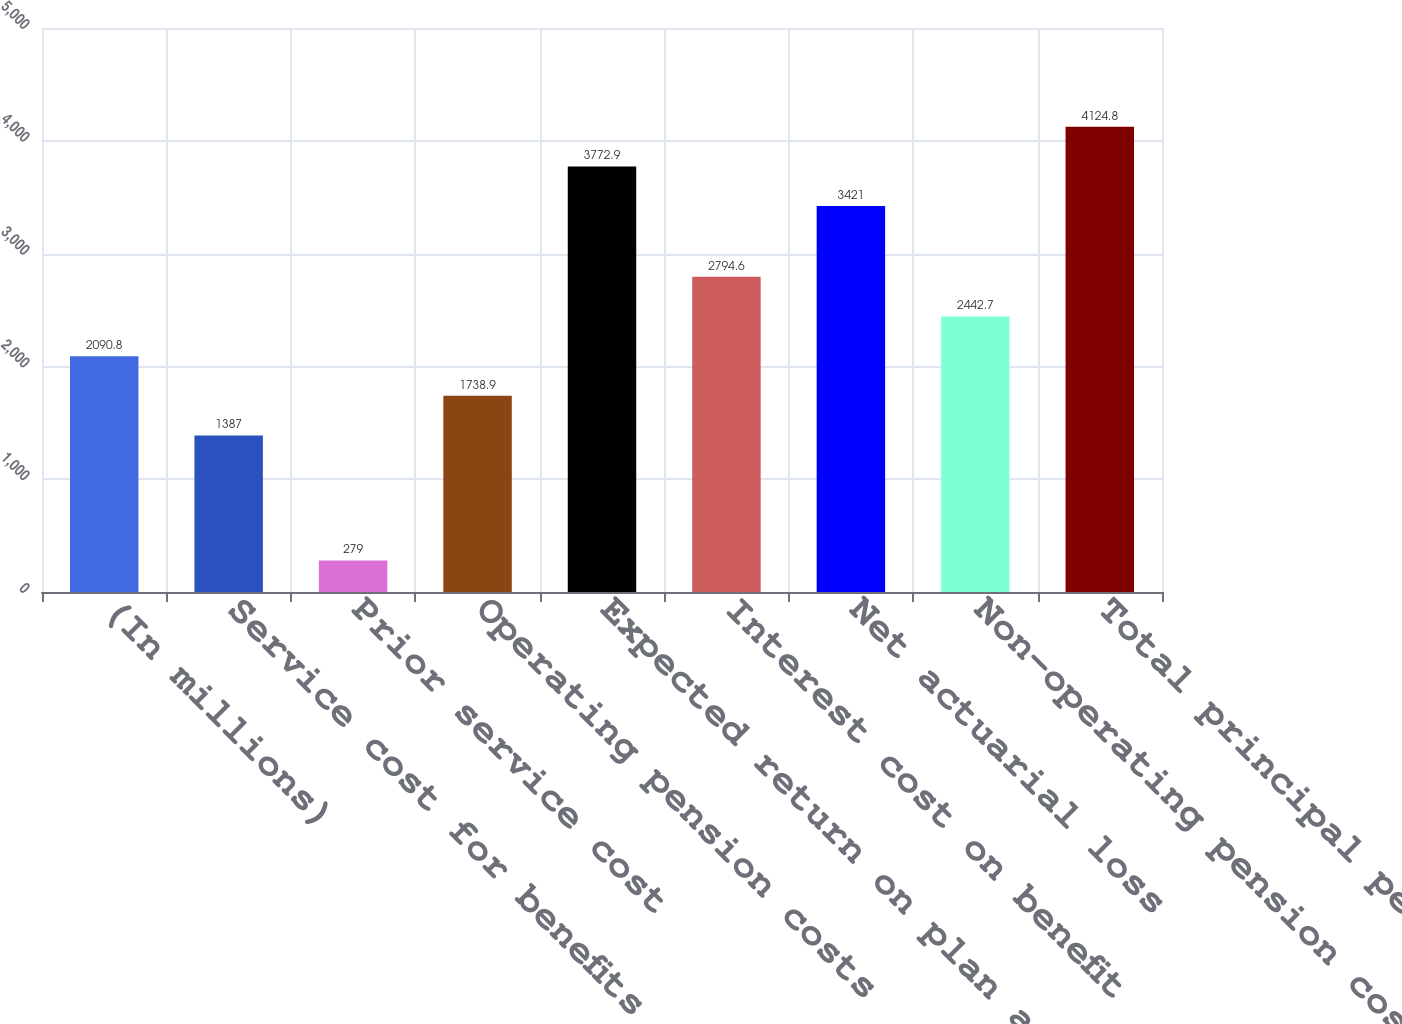<chart> <loc_0><loc_0><loc_500><loc_500><bar_chart><fcel>(In millions)<fcel>Service cost for benefits<fcel>Prior service cost<fcel>Operating pension costs<fcel>Expected return on plan assets<fcel>Interest cost on benefit<fcel>Net actuarial loss<fcel>Non-operating pension costs<fcel>Total principal pension plans<nl><fcel>2090.8<fcel>1387<fcel>279<fcel>1738.9<fcel>3772.9<fcel>2794.6<fcel>3421<fcel>2442.7<fcel>4124.8<nl></chart> 